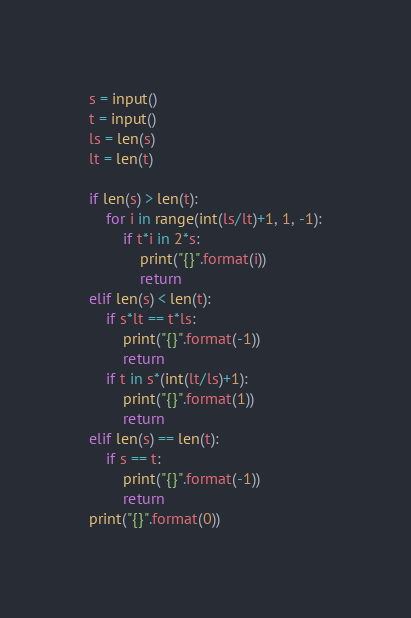<code> <loc_0><loc_0><loc_500><loc_500><_Python_>s = input()
t = input()
ls = len(s)
lt = len(t)

if len(s) > len(t):
    for i in range(int(ls/lt)+1, 1, -1):
        if t*i in 2*s:
            print("{}".format(i))
            return
elif len(s) < len(t):
    if s*lt == t*ls:
        print("{}".format(-1))
        return
    if t in s*(int(lt/ls)+1):
        print("{}".format(1))
        return
elif len(s) == len(t):
    if s == t:
        print("{}".format(-1))
        return
print("{}".format(0))</code> 